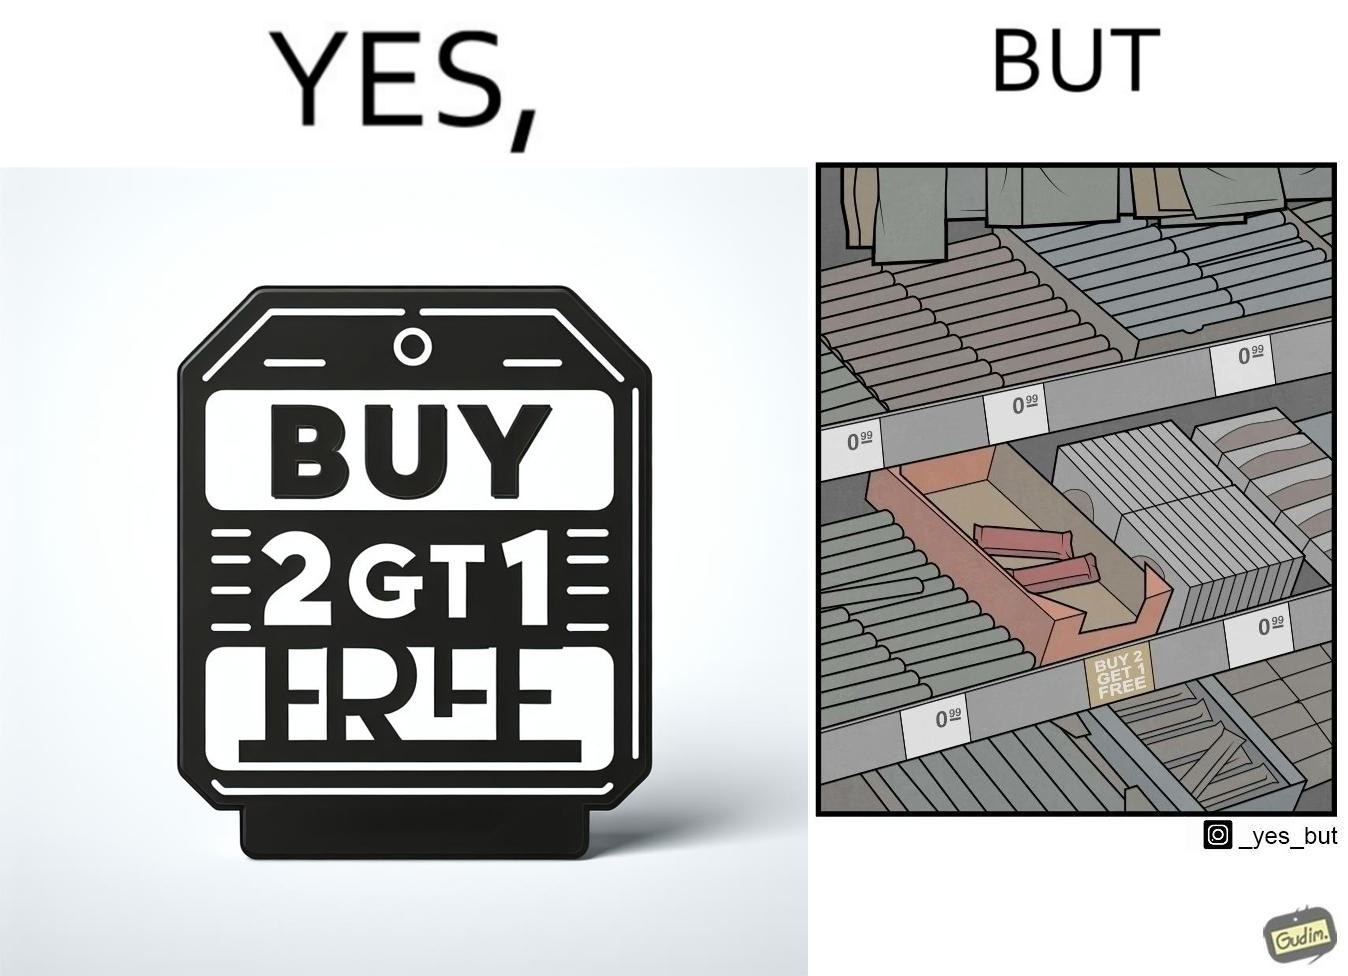Describe what you see in the left and right parts of this image. In the left part of the image: The image shows a label saying "BUY 2 GET 1 FREE" which means that on a purchase of two unit of this product, the buyer would get one more unit for free. In the right part of the image: The image shows two units of a product that is labelled "BUY 2 GET 1 FREE". 